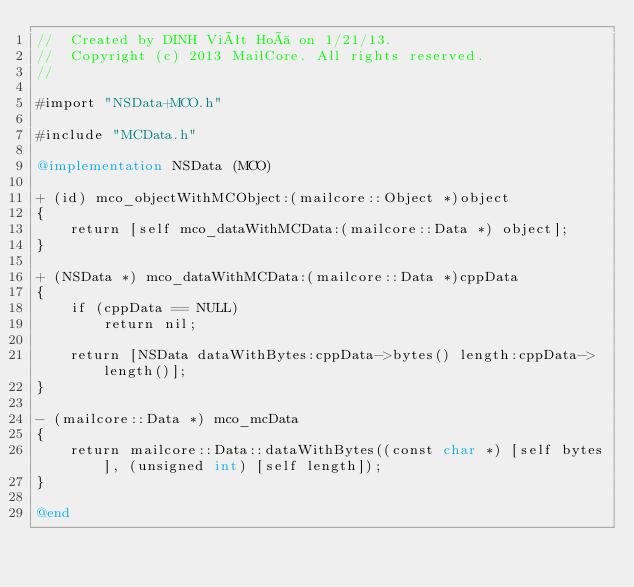<code> <loc_0><loc_0><loc_500><loc_500><_ObjectiveC_>//  Created by DINH Viêt Hoà on 1/21/13.
//  Copyright (c) 2013 MailCore. All rights reserved.
//

#import "NSData+MCO.h"

#include "MCData.h"

@implementation NSData (MCO)

+ (id) mco_objectWithMCObject:(mailcore::Object *)object
{
    return [self mco_dataWithMCData:(mailcore::Data *) object];
}

+ (NSData *) mco_dataWithMCData:(mailcore::Data *)cppData
{
    if (cppData == NULL)
        return nil;
    
    return [NSData dataWithBytes:cppData->bytes() length:cppData->length()];
}

- (mailcore::Data *) mco_mcData
{
    return mailcore::Data::dataWithBytes((const char *) [self bytes], (unsigned int) [self length]);
}

@end
</code> 